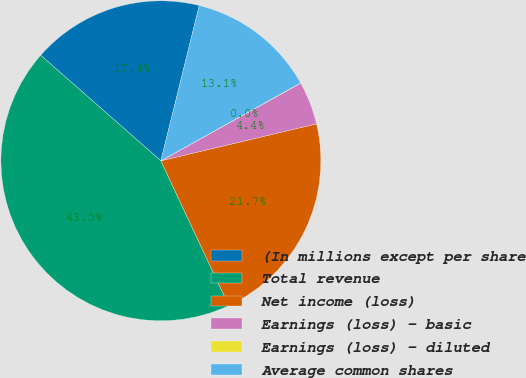Convert chart to OTSL. <chart><loc_0><loc_0><loc_500><loc_500><pie_chart><fcel>(In millions except per share<fcel>Total revenue<fcel>Net income (loss)<fcel>Earnings (loss) - basic<fcel>Earnings (loss) - diluted<fcel>Average common shares<nl><fcel>17.39%<fcel>43.45%<fcel>21.73%<fcel>4.36%<fcel>0.02%<fcel>13.05%<nl></chart> 